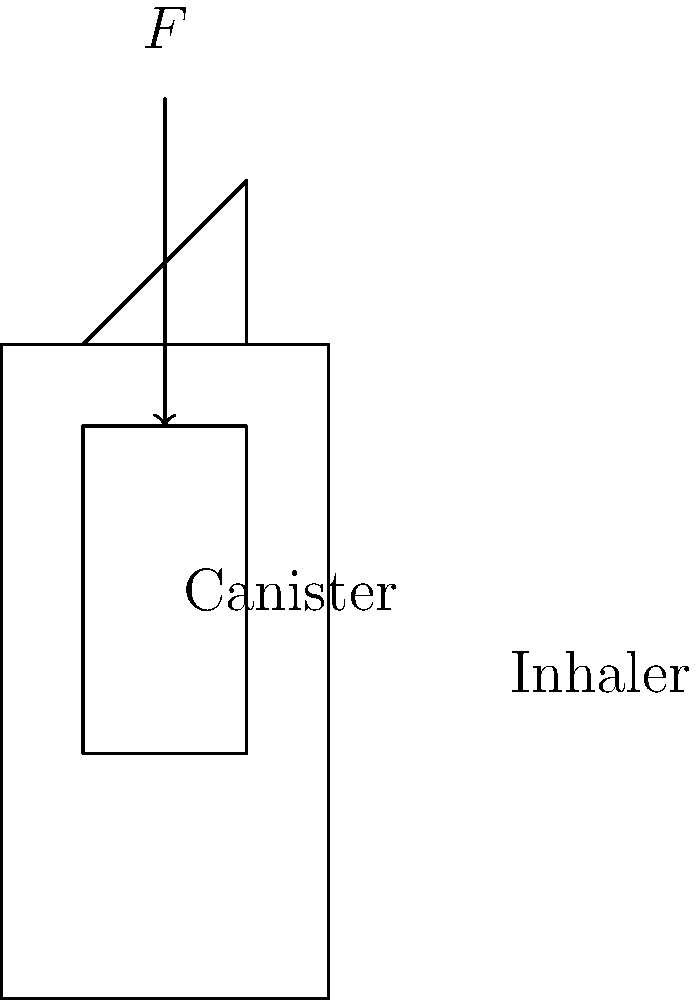The diagram shows a simplified inhaler with its canister. If the force required to compress the canister is 30 Newtons (N), what is the minimum hand strength needed to operate the inhaler effectively? To answer this question, we need to understand the basic principles of force application:

1. The force diagram shows a downward force $F$ applied to the canister of the inhaler.

2. In this simplified model, the force required to compress the canister is directly equal to the force that needs to be applied by the hand.

3. We are given that the force required to compress the canister is 30 Newtons (N).

4. In mechanical terms, the minimum hand strength needed would be equal to the force required to compress the canister.

5. Therefore, the minimum hand strength needed to operate the inhaler effectively is also 30 Newtons (N).

It's important to note that in real-life situations, factors such as the design of the inhaler, friction, and the angle at which force is applied might slightly affect the required hand strength. However, for the purposes of this simplified model, we assume a direct relationship between the compression force and the required hand strength.
Answer: 30 Newtons (N) 